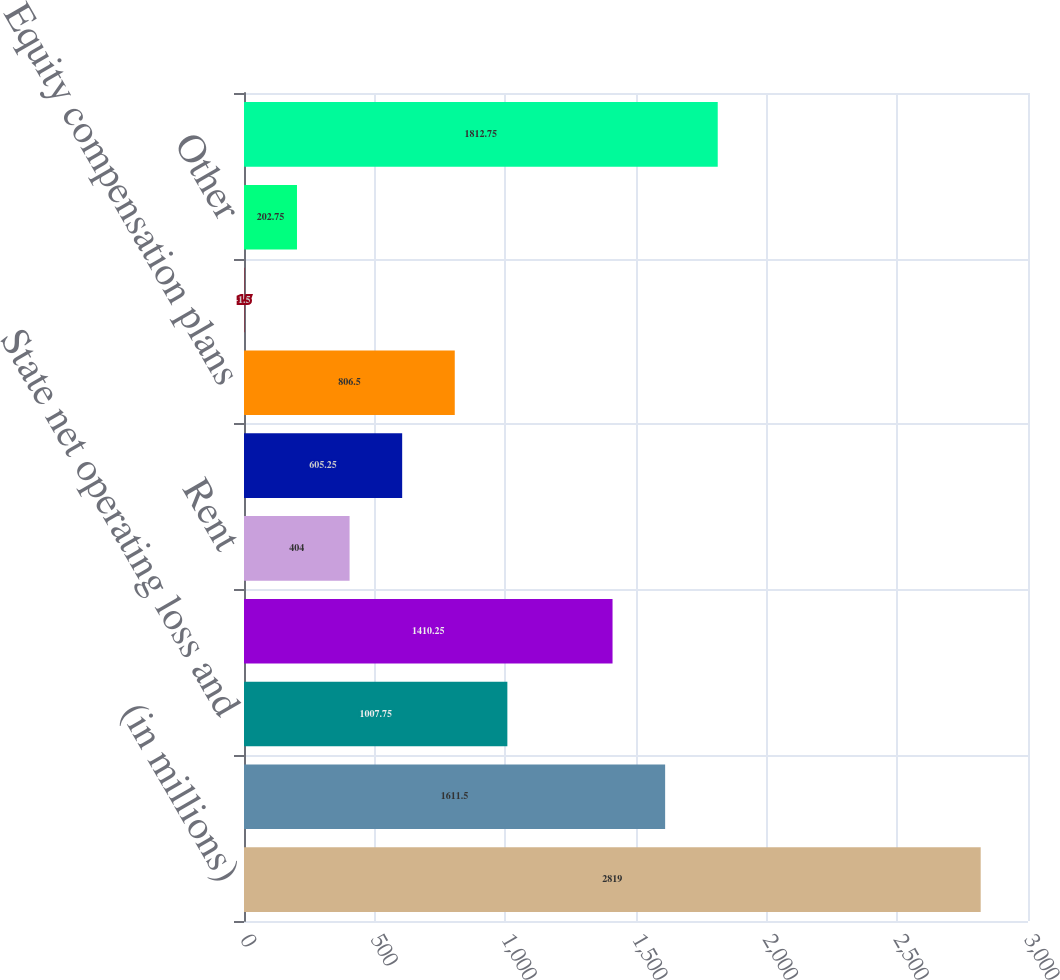Convert chart. <chart><loc_0><loc_0><loc_500><loc_500><bar_chart><fcel>(in millions)<fcel>Deferred interest<fcel>State net operating loss and<fcel>Payroll and benefits<fcel>Rent<fcel>Accounts receivable<fcel>Equity compensation plans<fcel>Trade credits<fcel>Other<fcel>Total deferred tax assets<nl><fcel>2819<fcel>1611.5<fcel>1007.75<fcel>1410.25<fcel>404<fcel>605.25<fcel>806.5<fcel>1.5<fcel>202.75<fcel>1812.75<nl></chart> 